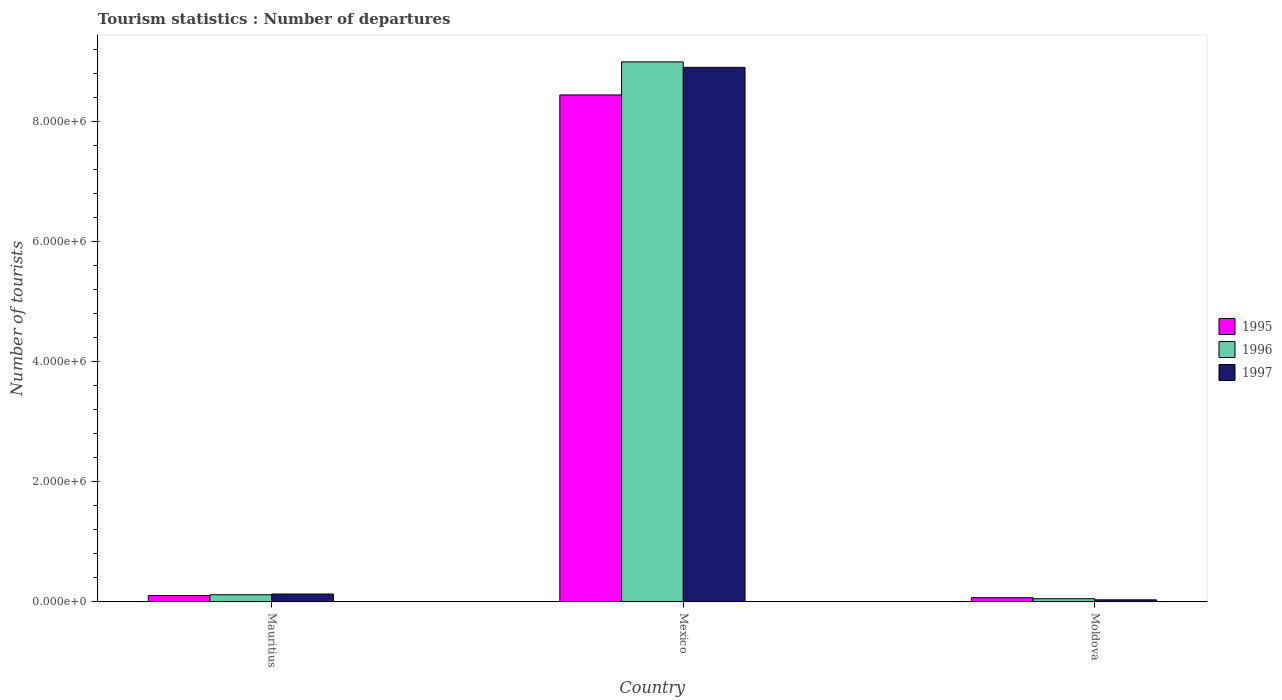How many bars are there on the 1st tick from the left?
Offer a terse response. 3. What is the label of the 1st group of bars from the left?
Provide a short and direct response. Mauritius. What is the number of tourist departures in 1997 in Mexico?
Your answer should be very brief. 8.91e+06. Across all countries, what is the maximum number of tourist departures in 1997?
Keep it short and to the point. 8.91e+06. Across all countries, what is the minimum number of tourist departures in 1996?
Give a very brief answer. 5.40e+04. In which country was the number of tourist departures in 1995 minimum?
Offer a very short reply. Moldova. What is the total number of tourist departures in 1995 in the graph?
Your response must be concise. 8.63e+06. What is the difference between the number of tourist departures in 1997 in Mauritius and that in Moldova?
Provide a short and direct response. 9.70e+04. What is the difference between the number of tourist departures in 1995 in Mauritius and the number of tourist departures in 1997 in Moldova?
Keep it short and to the point. 7.20e+04. What is the average number of tourist departures in 1997 per country?
Make the answer very short. 3.03e+06. What is the difference between the number of tourist departures of/in 1995 and number of tourist departures of/in 1996 in Mauritius?
Offer a very short reply. -1.30e+04. What is the ratio of the number of tourist departures in 1996 in Mauritius to that in Moldova?
Ensure brevity in your answer.  2.22. Is the number of tourist departures in 1995 in Mauritius less than that in Mexico?
Offer a very short reply. Yes. What is the difference between the highest and the second highest number of tourist departures in 1996?
Your answer should be compact. 8.95e+06. What is the difference between the highest and the lowest number of tourist departures in 1996?
Your answer should be very brief. 8.95e+06. In how many countries, is the number of tourist departures in 1995 greater than the average number of tourist departures in 1995 taken over all countries?
Ensure brevity in your answer.  1. Is the sum of the number of tourist departures in 1995 in Mauritius and Mexico greater than the maximum number of tourist departures in 1997 across all countries?
Offer a terse response. No. What does the 3rd bar from the right in Moldova represents?
Make the answer very short. 1995. How many bars are there?
Your answer should be very brief. 9. What is the difference between two consecutive major ticks on the Y-axis?
Provide a short and direct response. 2.00e+06. Are the values on the major ticks of Y-axis written in scientific E-notation?
Your response must be concise. Yes. Does the graph contain any zero values?
Keep it short and to the point. No. Does the graph contain grids?
Your response must be concise. No. Where does the legend appear in the graph?
Make the answer very short. Center right. How many legend labels are there?
Ensure brevity in your answer.  3. How are the legend labels stacked?
Provide a succinct answer. Vertical. What is the title of the graph?
Offer a terse response. Tourism statistics : Number of departures. Does "1983" appear as one of the legend labels in the graph?
Provide a short and direct response. No. What is the label or title of the Y-axis?
Make the answer very short. Number of tourists. What is the Number of tourists in 1995 in Mauritius?
Offer a terse response. 1.07e+05. What is the Number of tourists in 1996 in Mauritius?
Your response must be concise. 1.20e+05. What is the Number of tourists in 1997 in Mauritius?
Offer a terse response. 1.32e+05. What is the Number of tourists of 1995 in Mexico?
Make the answer very short. 8.45e+06. What is the Number of tourists of 1996 in Mexico?
Offer a very short reply. 9.00e+06. What is the Number of tourists of 1997 in Mexico?
Your answer should be very brief. 8.91e+06. What is the Number of tourists in 1995 in Moldova?
Your answer should be compact. 7.10e+04. What is the Number of tourists in 1996 in Moldova?
Give a very brief answer. 5.40e+04. What is the Number of tourists in 1997 in Moldova?
Make the answer very short. 3.50e+04. Across all countries, what is the maximum Number of tourists in 1995?
Give a very brief answer. 8.45e+06. Across all countries, what is the maximum Number of tourists in 1996?
Your response must be concise. 9.00e+06. Across all countries, what is the maximum Number of tourists in 1997?
Your answer should be very brief. 8.91e+06. Across all countries, what is the minimum Number of tourists in 1995?
Make the answer very short. 7.10e+04. Across all countries, what is the minimum Number of tourists of 1996?
Provide a short and direct response. 5.40e+04. Across all countries, what is the minimum Number of tourists in 1997?
Your answer should be compact. 3.50e+04. What is the total Number of tourists in 1995 in the graph?
Keep it short and to the point. 8.63e+06. What is the total Number of tourists in 1996 in the graph?
Offer a terse response. 9.18e+06. What is the total Number of tourists in 1997 in the graph?
Give a very brief answer. 9.08e+06. What is the difference between the Number of tourists in 1995 in Mauritius and that in Mexico?
Your response must be concise. -8.34e+06. What is the difference between the Number of tourists in 1996 in Mauritius and that in Mexico?
Ensure brevity in your answer.  -8.88e+06. What is the difference between the Number of tourists of 1997 in Mauritius and that in Mexico?
Offer a very short reply. -8.78e+06. What is the difference between the Number of tourists of 1995 in Mauritius and that in Moldova?
Offer a terse response. 3.60e+04. What is the difference between the Number of tourists in 1996 in Mauritius and that in Moldova?
Offer a terse response. 6.60e+04. What is the difference between the Number of tourists of 1997 in Mauritius and that in Moldova?
Your response must be concise. 9.70e+04. What is the difference between the Number of tourists of 1995 in Mexico and that in Moldova?
Your answer should be very brief. 8.38e+06. What is the difference between the Number of tourists in 1996 in Mexico and that in Moldova?
Give a very brief answer. 8.95e+06. What is the difference between the Number of tourists of 1997 in Mexico and that in Moldova?
Offer a terse response. 8.88e+06. What is the difference between the Number of tourists in 1995 in Mauritius and the Number of tourists in 1996 in Mexico?
Give a very brief answer. -8.89e+06. What is the difference between the Number of tourists of 1995 in Mauritius and the Number of tourists of 1997 in Mexico?
Your answer should be very brief. -8.80e+06. What is the difference between the Number of tourists of 1996 in Mauritius and the Number of tourists of 1997 in Mexico?
Offer a very short reply. -8.79e+06. What is the difference between the Number of tourists in 1995 in Mauritius and the Number of tourists in 1996 in Moldova?
Give a very brief answer. 5.30e+04. What is the difference between the Number of tourists of 1995 in Mauritius and the Number of tourists of 1997 in Moldova?
Make the answer very short. 7.20e+04. What is the difference between the Number of tourists in 1996 in Mauritius and the Number of tourists in 1997 in Moldova?
Provide a short and direct response. 8.50e+04. What is the difference between the Number of tourists of 1995 in Mexico and the Number of tourists of 1996 in Moldova?
Ensure brevity in your answer.  8.40e+06. What is the difference between the Number of tourists of 1995 in Mexico and the Number of tourists of 1997 in Moldova?
Provide a short and direct response. 8.42e+06. What is the difference between the Number of tourists of 1996 in Mexico and the Number of tourists of 1997 in Moldova?
Your answer should be compact. 8.97e+06. What is the average Number of tourists of 1995 per country?
Provide a short and direct response. 2.88e+06. What is the average Number of tourists in 1996 per country?
Make the answer very short. 3.06e+06. What is the average Number of tourists in 1997 per country?
Give a very brief answer. 3.03e+06. What is the difference between the Number of tourists in 1995 and Number of tourists in 1996 in Mauritius?
Your answer should be compact. -1.30e+04. What is the difference between the Number of tourists of 1995 and Number of tourists of 1997 in Mauritius?
Offer a very short reply. -2.50e+04. What is the difference between the Number of tourists of 1996 and Number of tourists of 1997 in Mauritius?
Keep it short and to the point. -1.20e+04. What is the difference between the Number of tourists in 1995 and Number of tourists in 1996 in Mexico?
Offer a terse response. -5.51e+05. What is the difference between the Number of tourists in 1995 and Number of tourists in 1997 in Mexico?
Offer a very short reply. -4.60e+05. What is the difference between the Number of tourists of 1996 and Number of tourists of 1997 in Mexico?
Make the answer very short. 9.10e+04. What is the difference between the Number of tourists in 1995 and Number of tourists in 1996 in Moldova?
Keep it short and to the point. 1.70e+04. What is the difference between the Number of tourists of 1995 and Number of tourists of 1997 in Moldova?
Provide a short and direct response. 3.60e+04. What is the difference between the Number of tourists in 1996 and Number of tourists in 1997 in Moldova?
Make the answer very short. 1.90e+04. What is the ratio of the Number of tourists of 1995 in Mauritius to that in Mexico?
Your response must be concise. 0.01. What is the ratio of the Number of tourists of 1996 in Mauritius to that in Mexico?
Your response must be concise. 0.01. What is the ratio of the Number of tourists of 1997 in Mauritius to that in Mexico?
Provide a short and direct response. 0.01. What is the ratio of the Number of tourists in 1995 in Mauritius to that in Moldova?
Provide a short and direct response. 1.51. What is the ratio of the Number of tourists of 1996 in Mauritius to that in Moldova?
Make the answer very short. 2.22. What is the ratio of the Number of tourists in 1997 in Mauritius to that in Moldova?
Your answer should be compact. 3.77. What is the ratio of the Number of tourists in 1995 in Mexico to that in Moldova?
Make the answer very short. 119.01. What is the ratio of the Number of tourists of 1996 in Mexico to that in Moldova?
Your answer should be compact. 166.69. What is the ratio of the Number of tourists in 1997 in Mexico to that in Moldova?
Your answer should be very brief. 254.57. What is the difference between the highest and the second highest Number of tourists in 1995?
Provide a short and direct response. 8.34e+06. What is the difference between the highest and the second highest Number of tourists of 1996?
Your answer should be compact. 8.88e+06. What is the difference between the highest and the second highest Number of tourists of 1997?
Your response must be concise. 8.78e+06. What is the difference between the highest and the lowest Number of tourists in 1995?
Ensure brevity in your answer.  8.38e+06. What is the difference between the highest and the lowest Number of tourists in 1996?
Make the answer very short. 8.95e+06. What is the difference between the highest and the lowest Number of tourists in 1997?
Your answer should be very brief. 8.88e+06. 